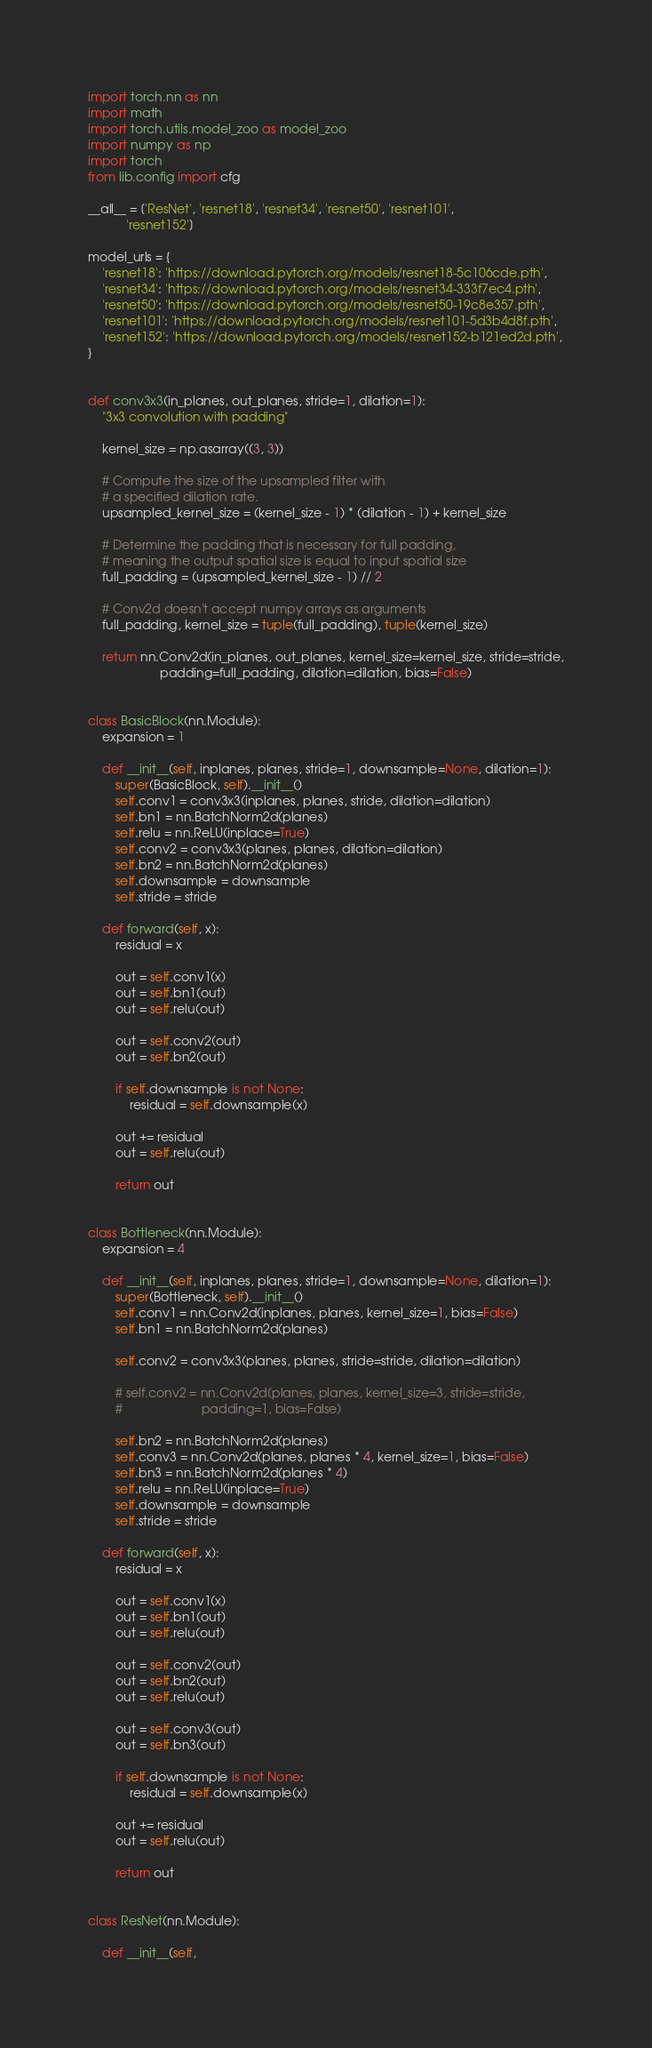Convert code to text. <code><loc_0><loc_0><loc_500><loc_500><_Python_>import torch.nn as nn
import math
import torch.utils.model_zoo as model_zoo
import numpy as np
import torch
from lib.config import cfg

__all__ = ['ResNet', 'resnet18', 'resnet34', 'resnet50', 'resnet101',
           'resnet152']

model_urls = {
    'resnet18': 'https://download.pytorch.org/models/resnet18-5c106cde.pth',
    'resnet34': 'https://download.pytorch.org/models/resnet34-333f7ec4.pth',
    'resnet50': 'https://download.pytorch.org/models/resnet50-19c8e357.pth',
    'resnet101': 'https://download.pytorch.org/models/resnet101-5d3b4d8f.pth',
    'resnet152': 'https://download.pytorch.org/models/resnet152-b121ed2d.pth',
}


def conv3x3(in_planes, out_planes, stride=1, dilation=1):
    "3x3 convolution with padding"

    kernel_size = np.asarray((3, 3))

    # Compute the size of the upsampled filter with
    # a specified dilation rate.
    upsampled_kernel_size = (kernel_size - 1) * (dilation - 1) + kernel_size

    # Determine the padding that is necessary for full padding,
    # meaning the output spatial size is equal to input spatial size
    full_padding = (upsampled_kernel_size - 1) // 2

    # Conv2d doesn't accept numpy arrays as arguments
    full_padding, kernel_size = tuple(full_padding), tuple(kernel_size)

    return nn.Conv2d(in_planes, out_planes, kernel_size=kernel_size, stride=stride,
                     padding=full_padding, dilation=dilation, bias=False)


class BasicBlock(nn.Module):
    expansion = 1

    def __init__(self, inplanes, planes, stride=1, downsample=None, dilation=1):
        super(BasicBlock, self).__init__()
        self.conv1 = conv3x3(inplanes, planes, stride, dilation=dilation)
        self.bn1 = nn.BatchNorm2d(planes)
        self.relu = nn.ReLU(inplace=True)
        self.conv2 = conv3x3(planes, planes, dilation=dilation)
        self.bn2 = nn.BatchNorm2d(planes)
        self.downsample = downsample
        self.stride = stride

    def forward(self, x):
        residual = x

        out = self.conv1(x)
        out = self.bn1(out)
        out = self.relu(out)

        out = self.conv2(out)
        out = self.bn2(out)

        if self.downsample is not None:
            residual = self.downsample(x)

        out += residual
        out = self.relu(out)

        return out


class Bottleneck(nn.Module):
    expansion = 4

    def __init__(self, inplanes, planes, stride=1, downsample=None, dilation=1):
        super(Bottleneck, self).__init__()
        self.conv1 = nn.Conv2d(inplanes, planes, kernel_size=1, bias=False)
        self.bn1 = nn.BatchNorm2d(planes)

        self.conv2 = conv3x3(planes, planes, stride=stride, dilation=dilation)

        # self.conv2 = nn.Conv2d(planes, planes, kernel_size=3, stride=stride,
        #                       padding=1, bias=False)

        self.bn2 = nn.BatchNorm2d(planes)
        self.conv3 = nn.Conv2d(planes, planes * 4, kernel_size=1, bias=False)
        self.bn3 = nn.BatchNorm2d(planes * 4)
        self.relu = nn.ReLU(inplace=True)
        self.downsample = downsample
        self.stride = stride

    def forward(self, x):
        residual = x

        out = self.conv1(x)
        out = self.bn1(out)
        out = self.relu(out)

        out = self.conv2(out)
        out = self.bn2(out)
        out = self.relu(out)

        out = self.conv3(out)
        out = self.bn3(out)

        if self.downsample is not None:
            residual = self.downsample(x)

        out += residual
        out = self.relu(out)

        return out


class ResNet(nn.Module):

    def __init__(self,</code> 